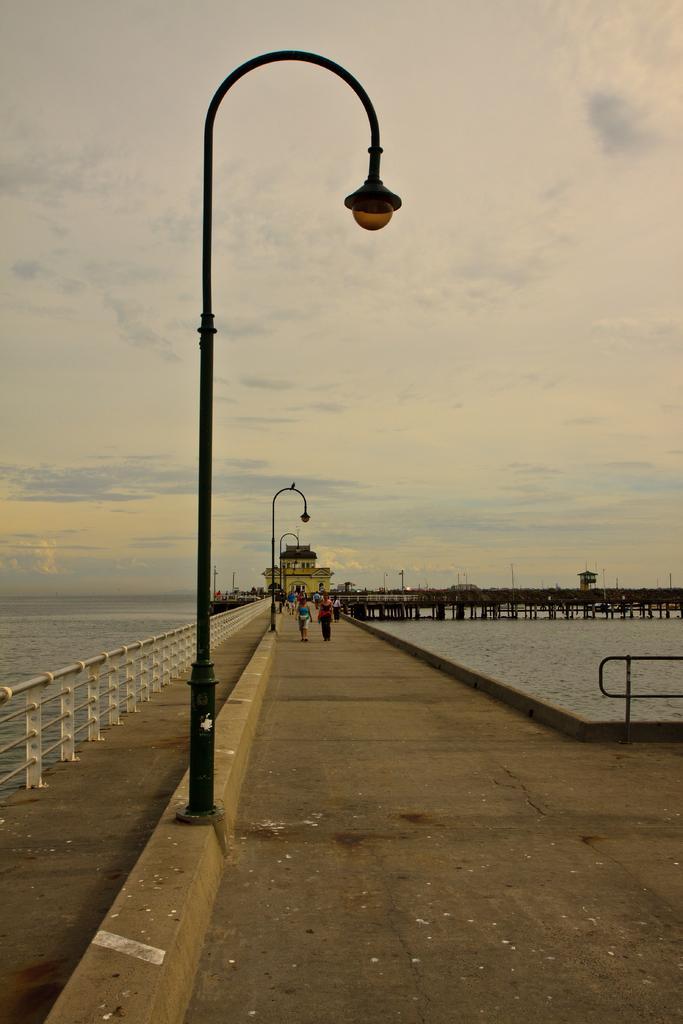What type of lighting is present in the image? There are street lights in the image. What are the people in the image doing? The people are standing on a bridge in the image. What can be seen in the background of the image? There is water, poles, and objects visible in the background of the image. What is visible in the sky in the background of the image? There are clouds in the sky in the background of the image. What time of day is it in the image, considering the presence of a bubble? There is no bubble present in the image, so it is not possible to determine the time of day based on that. 